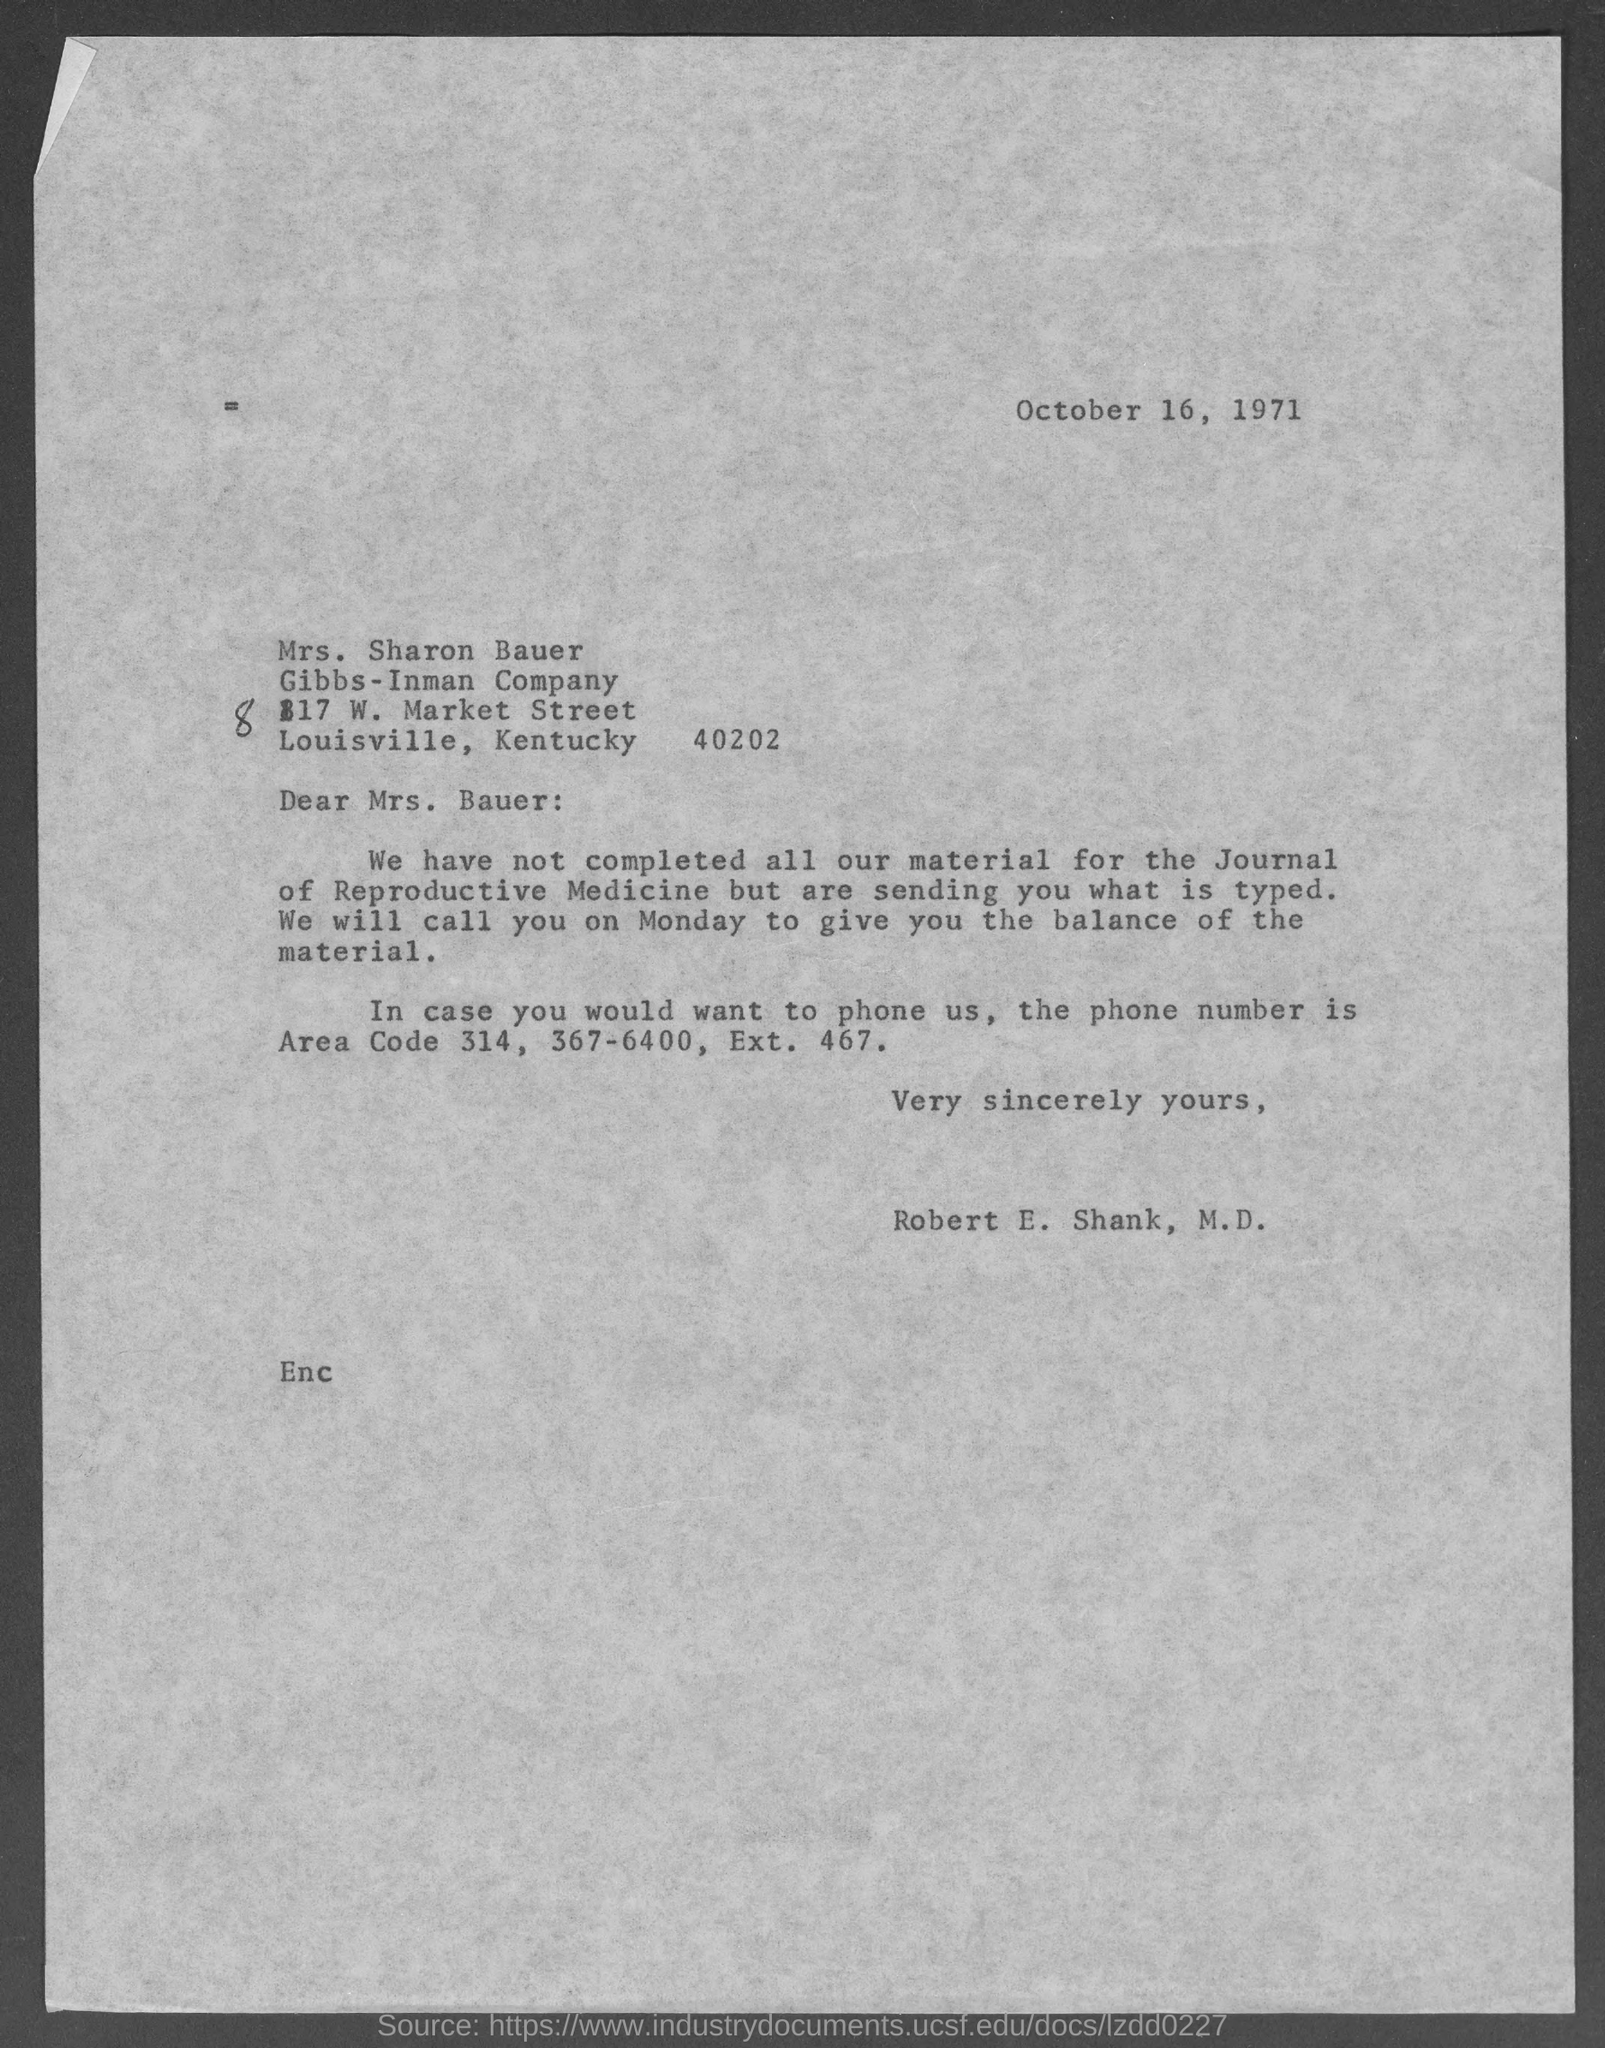Highlight a few significant elements in this photo. The date mentioned at the top of the document is October 16, 1971. The memorandum is addressed to Mrs. Bauer. 